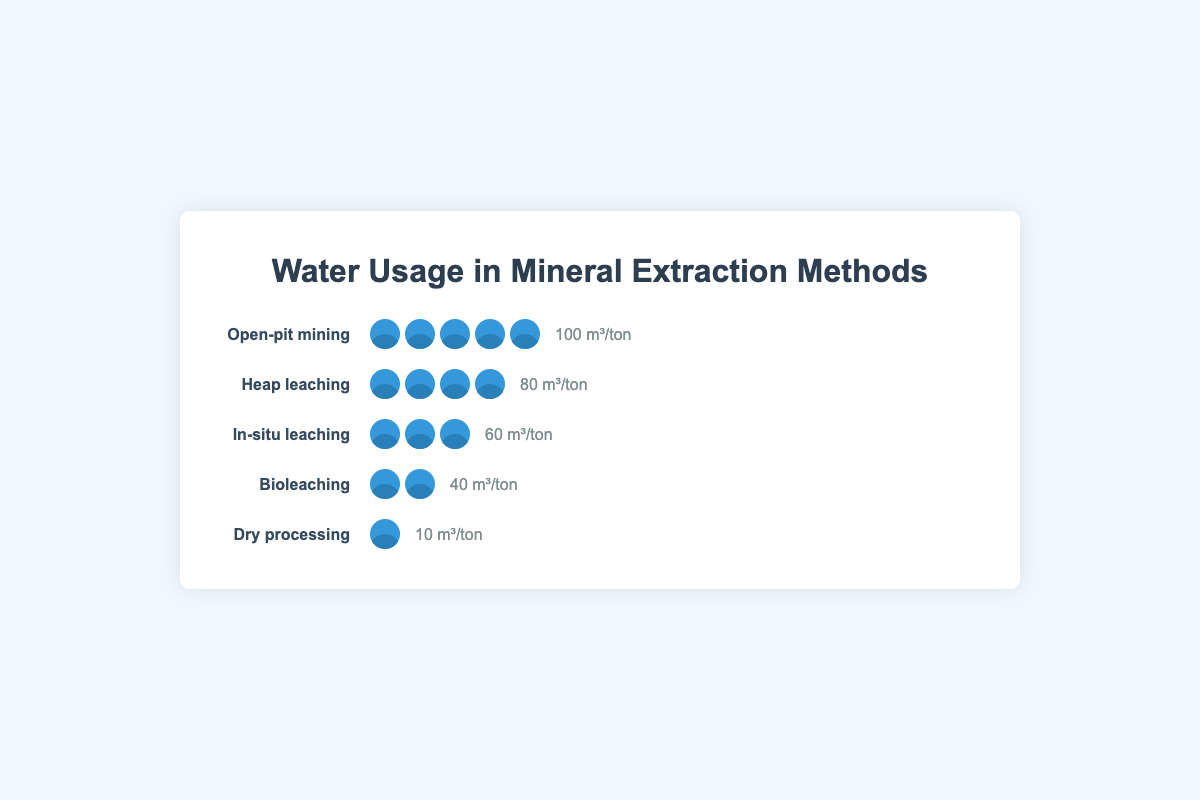What is the title of the figure? The title is typically placed at the top of the chart and is the first element to be seen
Answer: Water Usage in Mineral Extraction Methods Which method has the highest water usage? Scan through each method and compare their water usage values. Open-pit mining has the highest value at 100 cubic meters per ton of ore
Answer: Open-pit mining Which method has the lowest water usage? Comparing the water usage values, dry processing has the lowest value at 10 cubic meters per ton of ore
Answer: Dry processing How much more water does open-pit mining use compared to bioleaching? Subtract the water usage of bioleaching from open-pit mining: 100 - 40 = 60 cubic meters per ton of ore
Answer: 60 How many water icons are there for heap leaching? Each water icon represents a certain amount of water. Count the icons next to heap leaching, which are four
Answer: 4 What is the combined water usage of all the methods? Sum up the water usage for all methods: 100 (Open-pit) + 60 (In-situ) + 80 (Heap leaching) + 40 (Bioleaching) + 10 (Dry processing) = 290 cubic meters per ton of ore
Answer: 290 Which method is the most environmentally conscious in terms of water usage? The method with the lowest water usage can be considered the most environmentally conscious. Dry processing uses the least water
Answer: Dry processing What is the average water usage across all the methods listed? Add up water usage values of all methods and divide by the number of methods: (100 + 60 + 80 + 40 + 10) / 5 = 58 cubic meters per ton of ore
Answer: 58 How does the water usage of in-situ leaching compare to heap leaching? In-situ leaching uses 60 cubic meters per ton of ore, while heap leaching uses 80. In-situ leaching uses 20 cubic meters less water per ton of ore
Answer: 20 less 